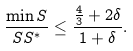Convert formula to latex. <formula><loc_0><loc_0><loc_500><loc_500>\frac { \min { S } } { S S ^ { * } } \leq \frac { \frac { 4 } { 3 } + 2 \delta } { 1 + \delta } .</formula> 